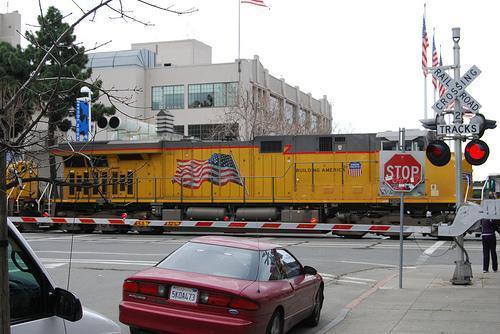How many trains?
Give a very brief answer. 1. 